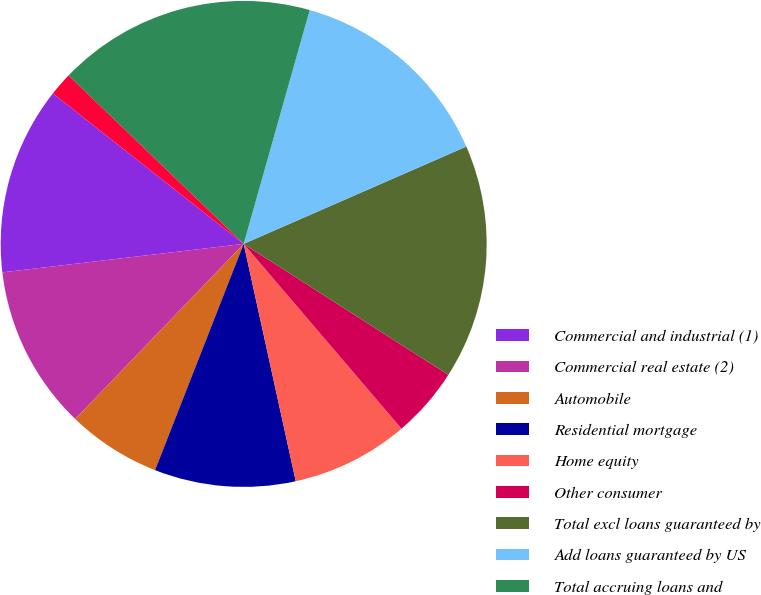Convert chart. <chart><loc_0><loc_0><loc_500><loc_500><pie_chart><fcel>Commercial and industrial (1)<fcel>Commercial real estate (2)<fcel>Automobile<fcel>Residential mortgage<fcel>Home equity<fcel>Other consumer<fcel>Total excl loans guaranteed by<fcel>Add loans guaranteed by US<fcel>Total accruing loans and<fcel>Excluding loans guaranteed by<nl><fcel>12.5%<fcel>10.94%<fcel>6.25%<fcel>9.38%<fcel>7.81%<fcel>4.69%<fcel>15.62%<fcel>14.06%<fcel>17.19%<fcel>1.56%<nl></chart> 